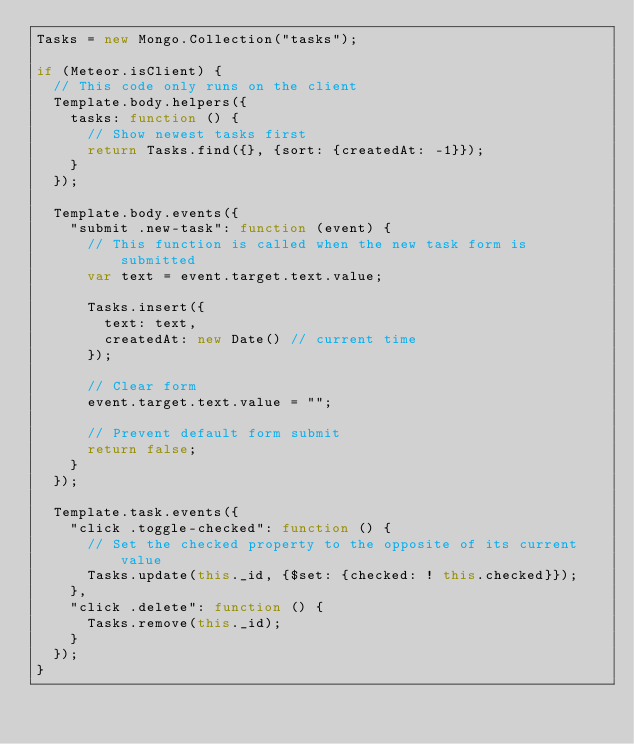<code> <loc_0><loc_0><loc_500><loc_500><_JavaScript_>Tasks = new Mongo.Collection("tasks");

if (Meteor.isClient) {
  // This code only runs on the client
  Template.body.helpers({
    tasks: function () {
      // Show newest tasks first
      return Tasks.find({}, {sort: {createdAt: -1}});
    }
  });

  Template.body.events({
    "submit .new-task": function (event) {
      // This function is called when the new task form is submitted
      var text = event.target.text.value;

      Tasks.insert({
        text: text,
        createdAt: new Date() // current time
      });

      // Clear form
      event.target.text.value = "";

      // Prevent default form submit
      return false;
    }
  });

  Template.task.events({
    "click .toggle-checked": function () {
      // Set the checked property to the opposite of its current value
      Tasks.update(this._id, {$set: {checked: ! this.checked}});
    },
    "click .delete": function () {
      Tasks.remove(this._id);
    }
  });
}
</code> 